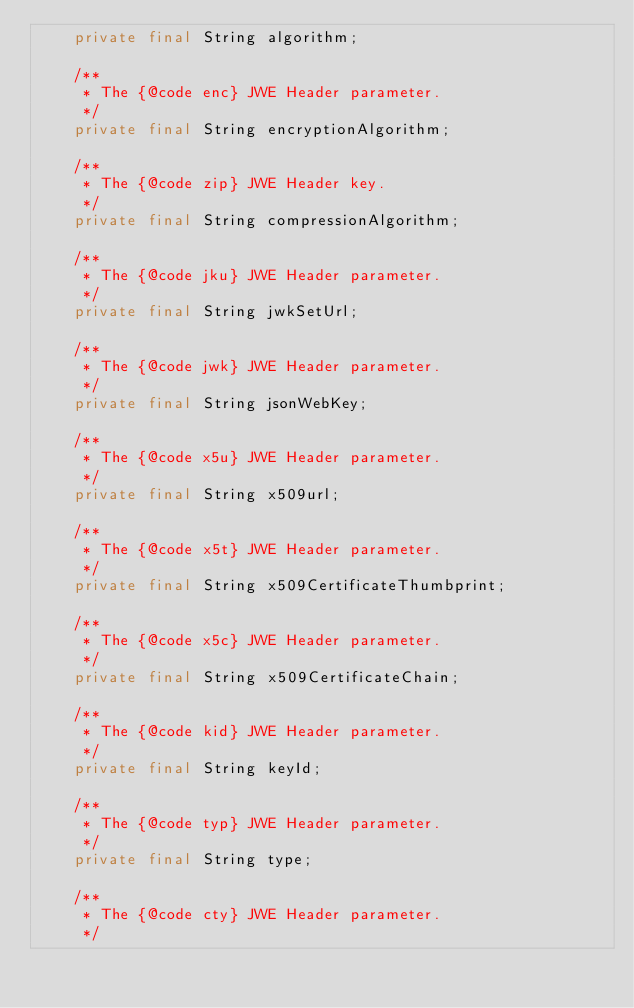<code> <loc_0><loc_0><loc_500><loc_500><_Java_>    private final String algorithm;
    
    /**
     * The {@code enc} JWE Header parameter.
     */
    private final String encryptionAlgorithm;
    
    /**
     * The {@code zip} JWE Header key.
     */
    private final String compressionAlgorithm;
    
    /**
     * The {@code jku} JWE Header parameter.
     */
    private final String jwkSetUrl;

    /**
     * The {@code jwk} JWE Header parameter.
     */
    private final String jsonWebKey;
    
    /**
     * The {@code x5u} JWE Header parameter.
     */
    private final String x509url;

    /**
     * The {@code x5t} JWE Header parameter.
     */
    private final String x509CertificateThumbprint;

    /**
     * The {@code x5c} JWE Header parameter.
     */
    private final String x509CertificateChain;
    
    /**
     * The {@code kid} JWE Header parameter.
     */
    private final String keyId;

    /**
     * The {@code typ} JWE Header parameter.
     */
    private final String type;

    /**
     * The {@code cty} JWE Header parameter.
     */</code> 